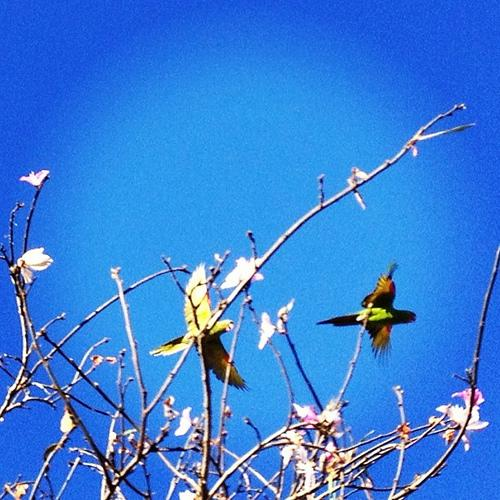Question: what is on the end of some branches?
Choices:
A. Leaves.
B. Flowers.
C. Bees.
D. Fruit.
Answer with the letter. Answer: B Question: what color is seen on the bird on the right?
Choices:
A. Blue.
B. Red.
C. Black.
D. Green.
Answer with the letter. Answer: D Question: what color is the sky?
Choices:
A. White.
B. Gray.
C. Pink.
D. Blue.
Answer with the letter. Answer: D 